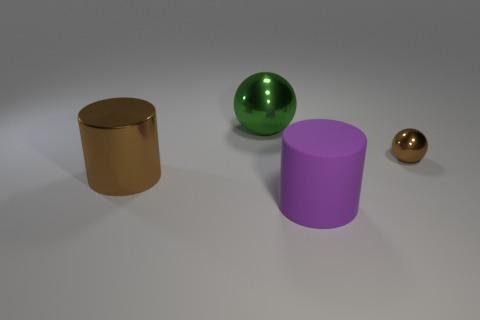Add 4 brown metal cylinders. How many objects exist? 8 Subtract all large matte cylinders. Subtract all green metal spheres. How many objects are left? 2 Add 4 purple matte objects. How many purple matte objects are left? 5 Add 1 purple cylinders. How many purple cylinders exist? 2 Subtract 0 gray cubes. How many objects are left? 4 